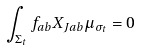Convert formula to latex. <formula><loc_0><loc_0><loc_500><loc_500>\int _ { \Sigma _ { t } } f _ { a b } X _ { J a b } \mu _ { \sigma _ { t } } = 0</formula> 